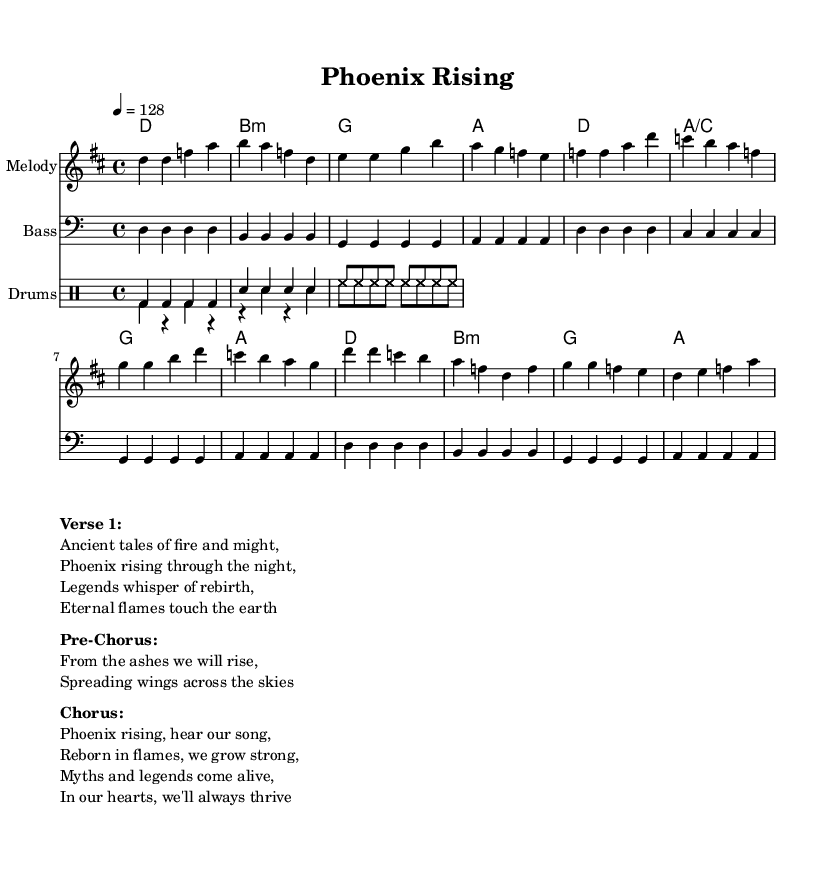What is the key signature of this music? The key signature is D major, which has two sharps (F# and C#). This can be identified in the global settings of the music sheet, where it explicitly states "\key d \major".
Answer: D major What is the time signature of the song? The time signature is 4/4, indicating there are four beats per measure. This is noted in the global settings of the music sheet as "\time 4/4".
Answer: 4/4 What is the tempo marking of this piece? The tempo marking is 128 beats per minute, indicated by "\tempo 4 = 128" in the global settings. This suggests a fast-paced feel, typical of upbeat K-Pop songs.
Answer: 128 What is the first note of the melody? The first note of the melody is D, as seen at the beginning of the melody section "\relative c'' { d4". This note sets the tone of the piece right from the first measure.
Answer: D How many measures are in the verse section? The verse section comprises four measures, which can be observed in the melody. Each group's rhythm shows D, F, A with the corresponding harmonies over four sets of notes.
Answer: 4 What themes are depicted in the song's lyrics? The themes depicted in the song's lyrics include rebirth and strength, as stated in the verse discussing the phoenix rising and legends about fire. These themes are evident from the poetic lines provided in the markup section.
Answer: Rebirth and strength How does the chorus relate to the song’s historical inspiration? The chorus references mythical themes by mentioning "Phoenix rising" and "myths and legends," aligning with ancient narratives about renewal and empowerment. This historical inspiration is reflected in the lyrics, suggesting a connection to cultural legends.
Answer: Myths and legends 